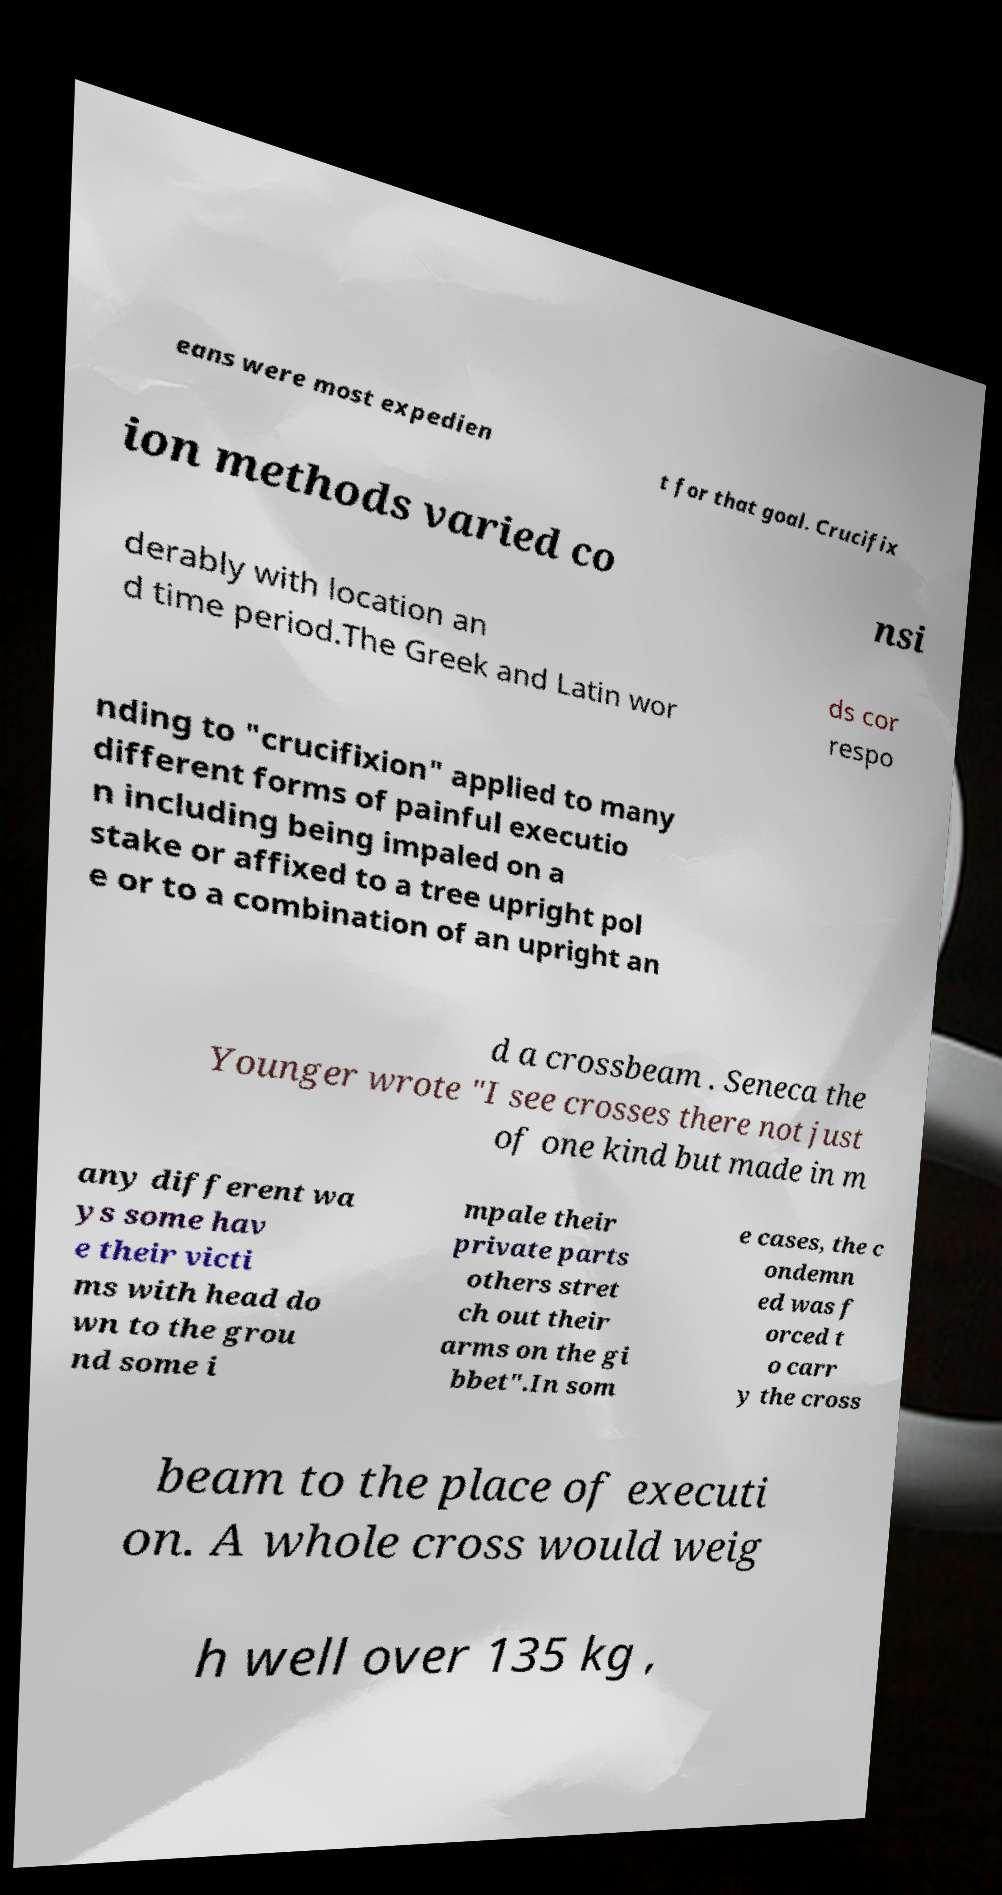Could you assist in decoding the text presented in this image and type it out clearly? eans were most expedien t for that goal. Crucifix ion methods varied co nsi derably with location an d time period.The Greek and Latin wor ds cor respo nding to "crucifixion" applied to many different forms of painful executio n including being impaled on a stake or affixed to a tree upright pol e or to a combination of an upright an d a crossbeam . Seneca the Younger wrote "I see crosses there not just of one kind but made in m any different wa ys some hav e their victi ms with head do wn to the grou nd some i mpale their private parts others stret ch out their arms on the gi bbet".In som e cases, the c ondemn ed was f orced t o carr y the cross beam to the place of executi on. A whole cross would weig h well over 135 kg , 